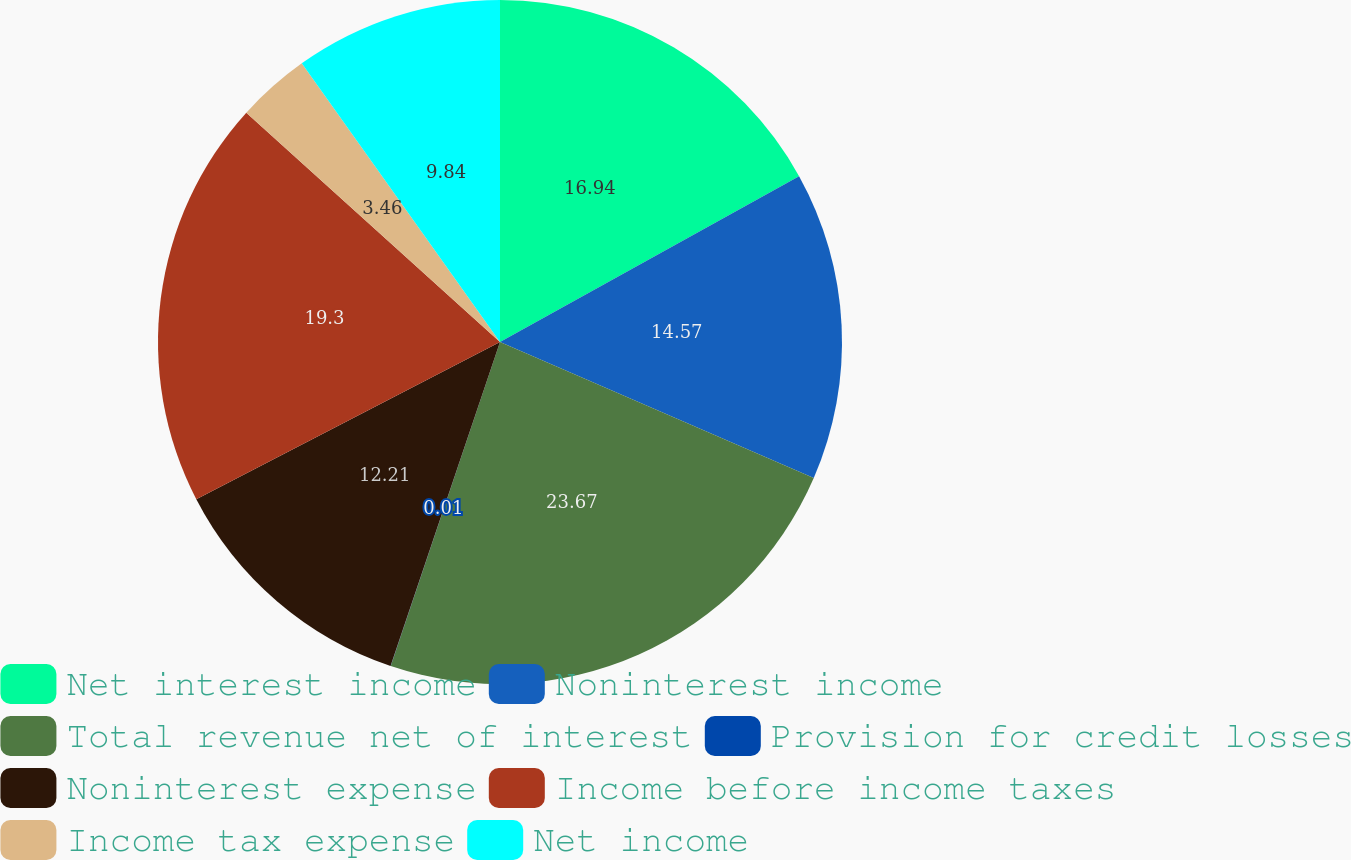Convert chart to OTSL. <chart><loc_0><loc_0><loc_500><loc_500><pie_chart><fcel>Net interest income<fcel>Noninterest income<fcel>Total revenue net of interest<fcel>Provision for credit losses<fcel>Noninterest expense<fcel>Income before income taxes<fcel>Income tax expense<fcel>Net income<nl><fcel>16.94%<fcel>14.57%<fcel>23.66%<fcel>0.01%<fcel>12.21%<fcel>19.3%<fcel>3.46%<fcel>9.84%<nl></chart> 